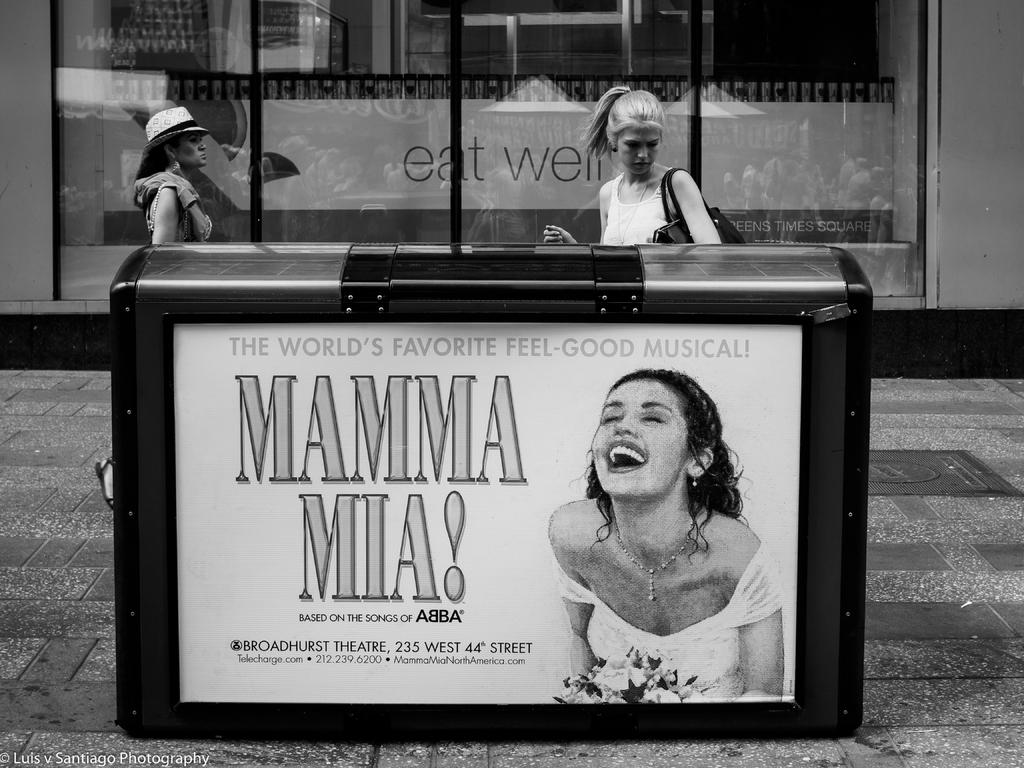What is the color scheme of the image? The image is black and white. What object is present in the image that contains something inside? There is a box in the image that contains a picture of a person and some text. How many people are in the image? There are two persons in the image. What are the two persons wearing? The two persons are wearing clothes. Where are the two persons located in the image? The two persons are in front of a glass door. What type of sign can be seen on the glass door in the image? There is no sign visible on the glass door in the image. Can you tell me how much the receipt costs for the items in the box? There is no receipt present in the image, and the cost of the items in the box cannot be determined. 